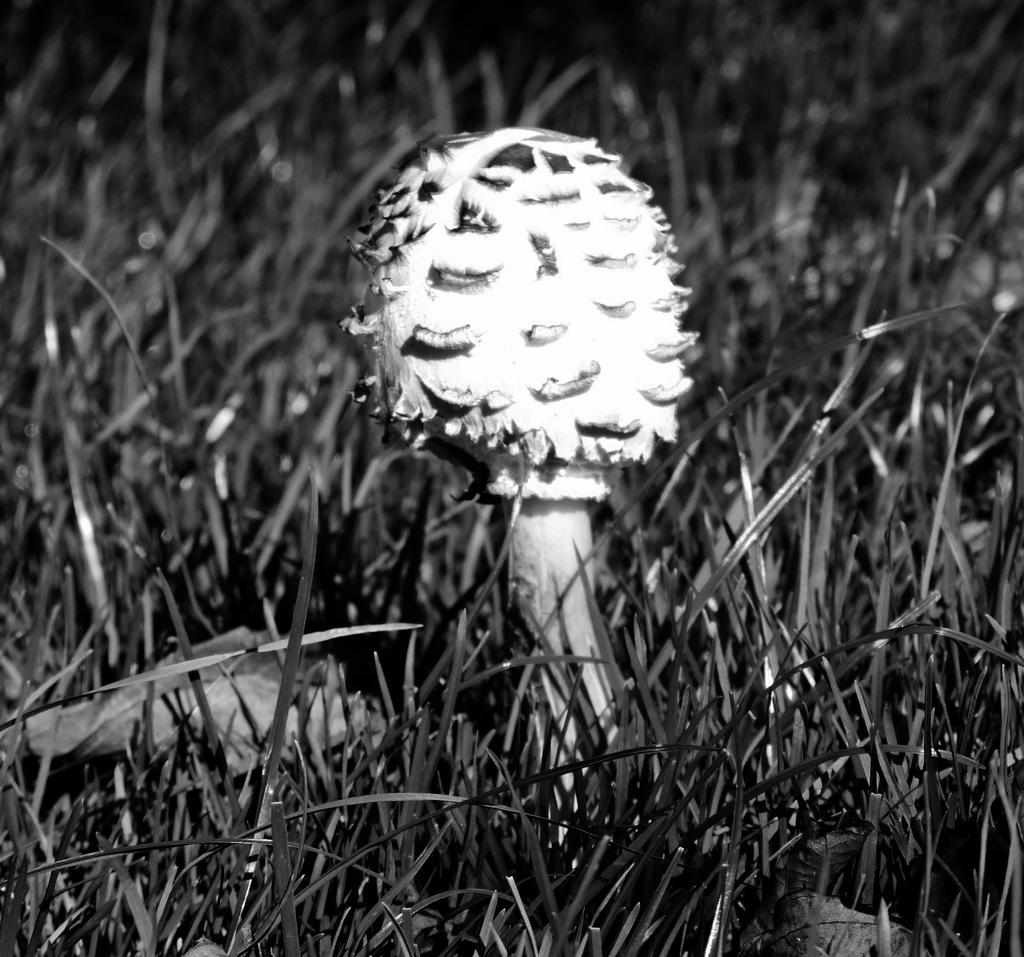What type of living organism can be seen in the image? There is a plant in the image. What is the color of the plant? The plant is white in color. What type of vegetation is at the bottom of the image? There is grass at the bottom of the image. What advice does the father give about planting the seed in the image? There is no father or seed present in the image, so it is not possible to answer that question. 